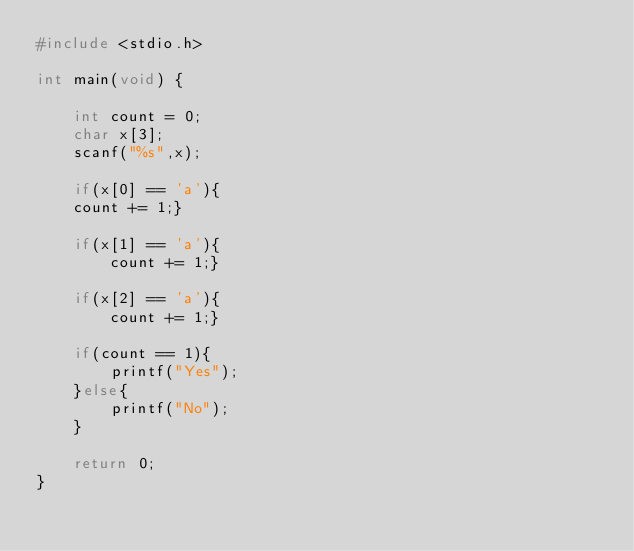Convert code to text. <code><loc_0><loc_0><loc_500><loc_500><_C_>#include <stdio.h>
 
int main(void) {
 
	int count = 0;
	char x[3];
	scanf("%s",x);
 
	if(x[0] == 'a'){
	count += 1;}
		
	if(x[1] == 'a'){
		count += 1;}
		
	if(x[2] == 'a'){
		count += 1;}
	
	if(count == 1){
		printf("Yes");
	}else{
		printf("No");
	}
	
	return 0;
}
</code> 